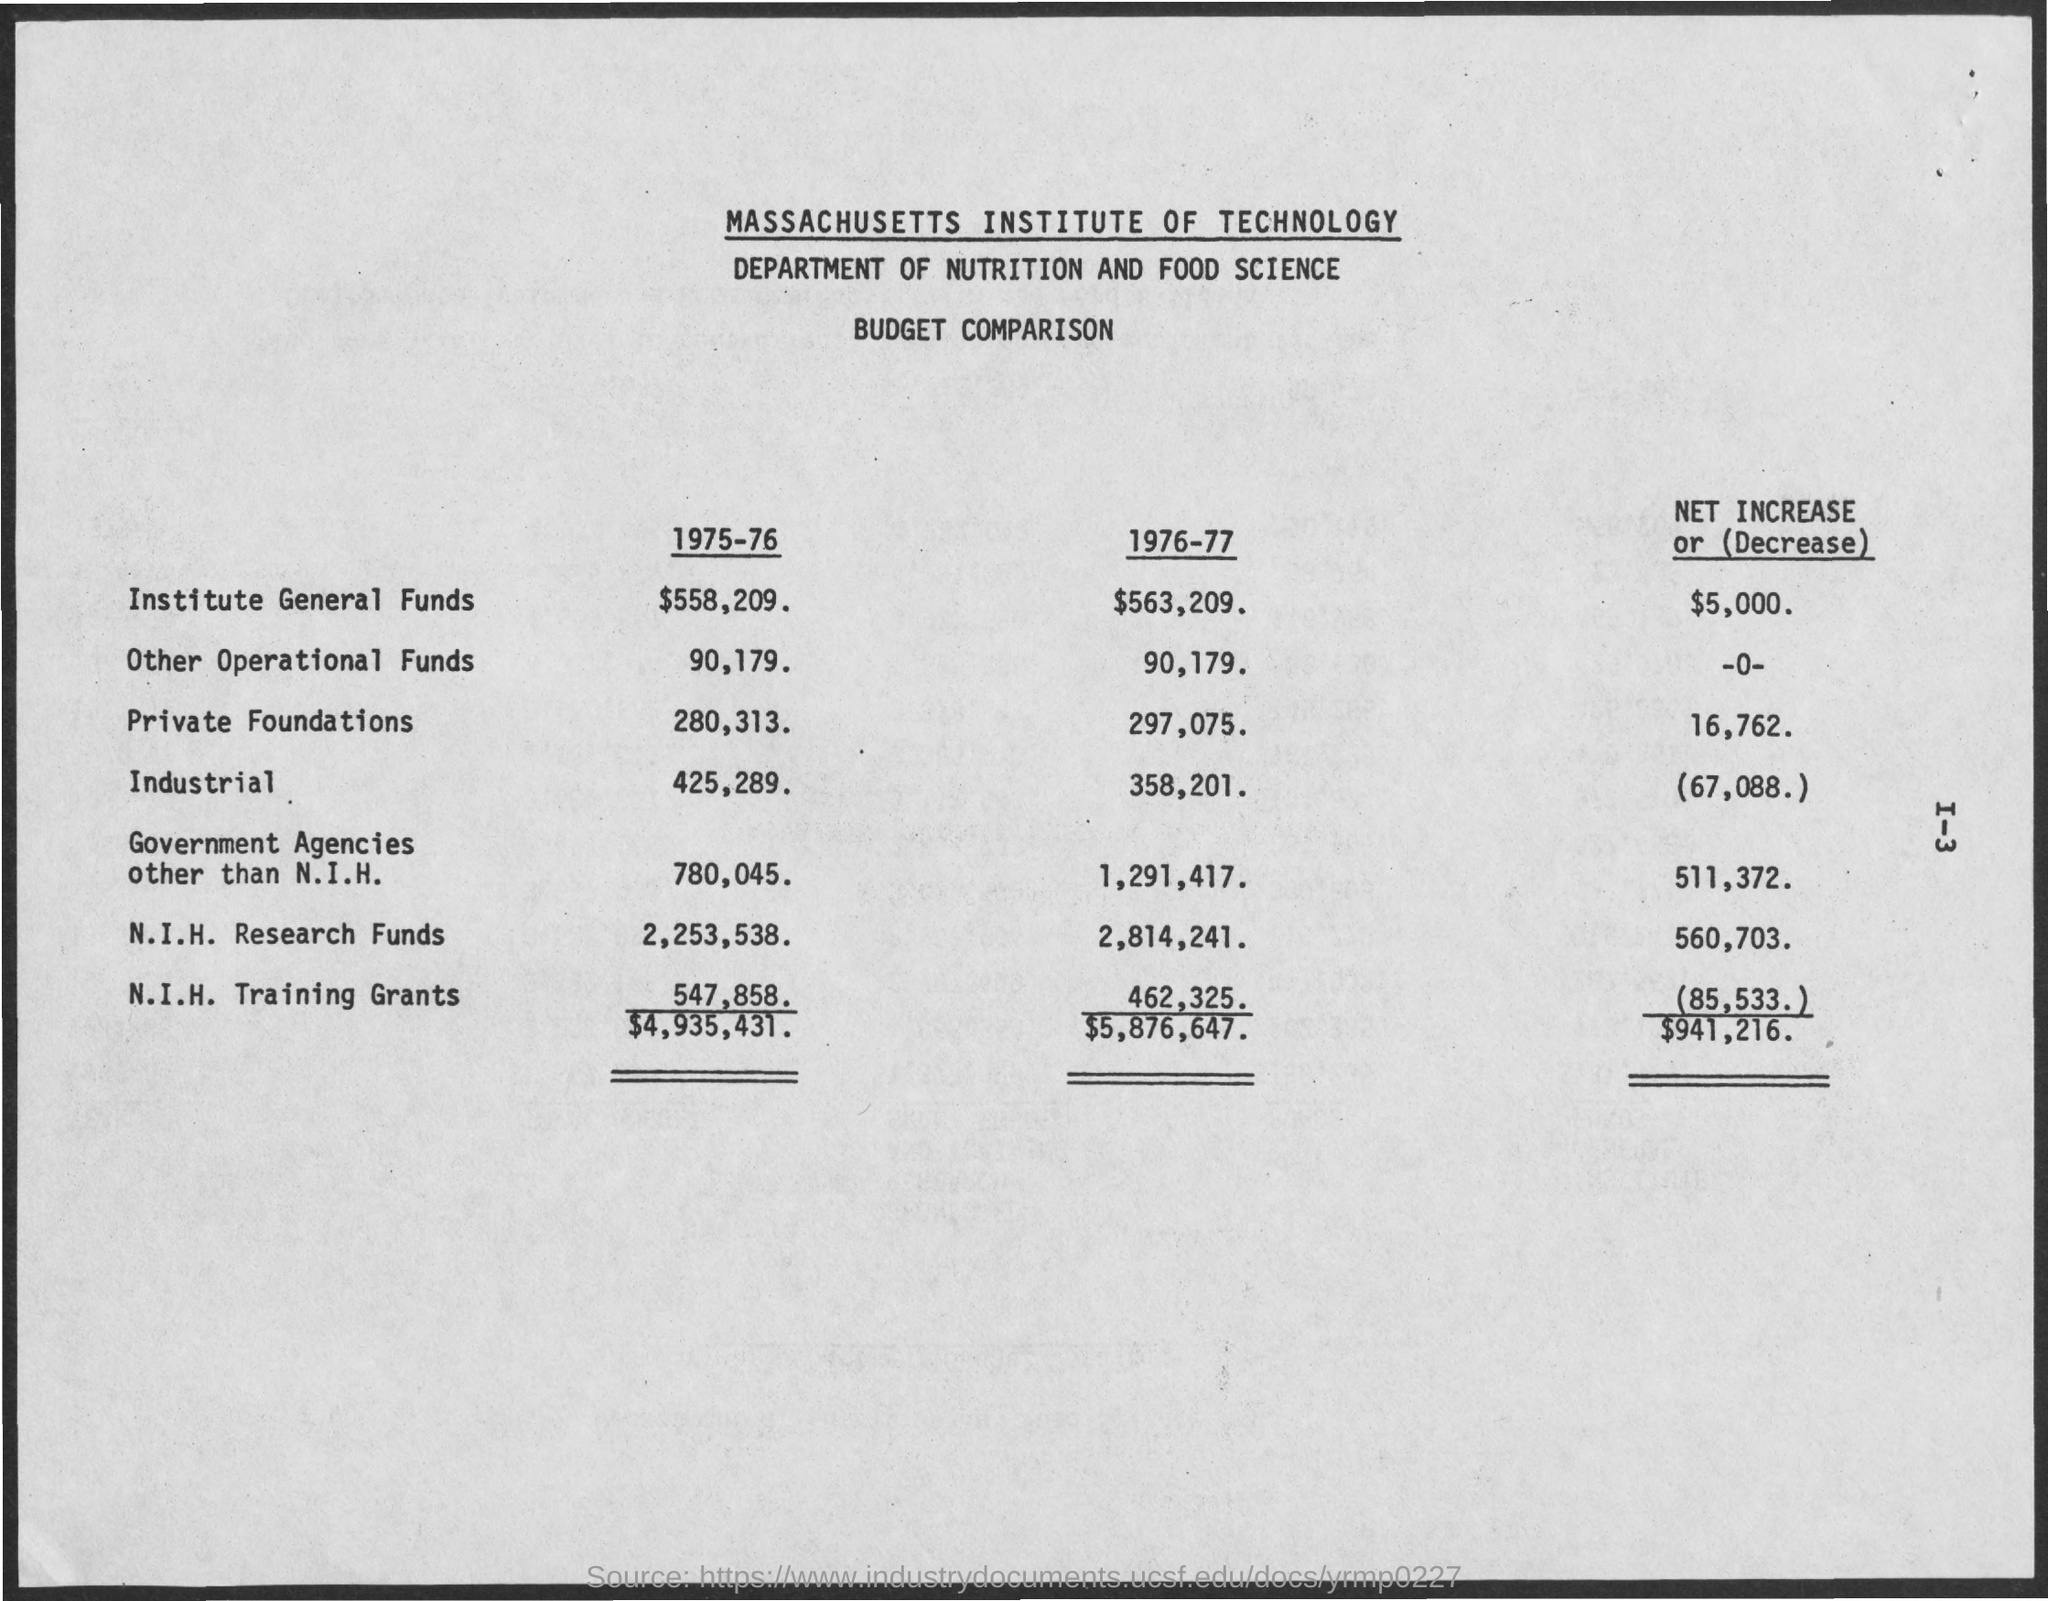Can you tell me the total budget for the MIT Department of Nutrition and Food Science for the year 1976-77? The total budget for the Massachusetts Institute of Technology's Department of Nutrition and Food Science in the year 1976-77 was $5,876,647, as indicated by the summation of all categories of funding on the document. 